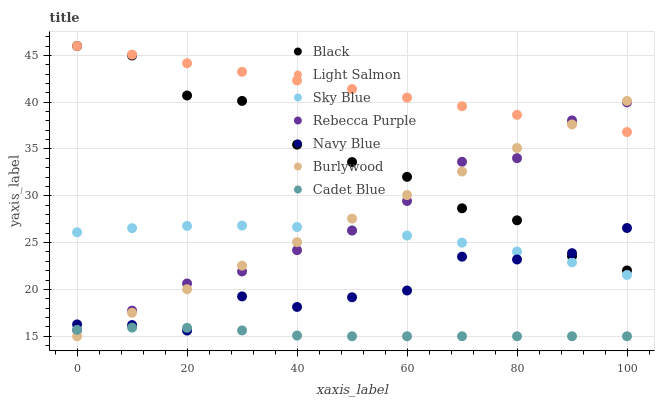Does Cadet Blue have the minimum area under the curve?
Answer yes or no. Yes. Does Light Salmon have the maximum area under the curve?
Answer yes or no. Yes. Does Burlywood have the minimum area under the curve?
Answer yes or no. No. Does Burlywood have the maximum area under the curve?
Answer yes or no. No. Is Burlywood the smoothest?
Answer yes or no. Yes. Is Black the roughest?
Answer yes or no. Yes. Is Cadet Blue the smoothest?
Answer yes or no. No. Is Cadet Blue the roughest?
Answer yes or no. No. Does Cadet Blue have the lowest value?
Answer yes or no. Yes. Does Navy Blue have the lowest value?
Answer yes or no. No. Does Black have the highest value?
Answer yes or no. Yes. Does Burlywood have the highest value?
Answer yes or no. No. Is Sky Blue less than Light Salmon?
Answer yes or no. Yes. Is Black greater than Sky Blue?
Answer yes or no. Yes. Does Cadet Blue intersect Rebecca Purple?
Answer yes or no. Yes. Is Cadet Blue less than Rebecca Purple?
Answer yes or no. No. Is Cadet Blue greater than Rebecca Purple?
Answer yes or no. No. Does Sky Blue intersect Light Salmon?
Answer yes or no. No. 